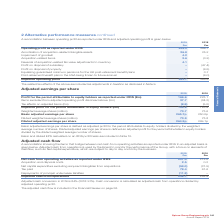According to Spirax Sarco Engineering Plc's financial document, What does the Board use Adjusted cash from operations for? to monitor the performance of the Group, with a focus on elements of cashflow, such as Net capital expenditure, which are subject to day to day control by the business. The document states: "djusted cash from operations is used by the Board to monitor the performance of the Group, with a focus on elements of cashflow, such as Net capital e..." Also, How is cash conversion calculated? as adjusted cash from operations divided by adjusted operating profit. The document states: "is 84% (2018: 91%). Cash conversion is calculated as adjusted cash from operations divided by adjusted operating profit...." Also, In which years was the adjusted cash conversion calculated in? The document shows two values: 2019 and 2018. From the document: "2019 2018 Profit for the period attributable to equity holders as reported under IFRS (£m) 166.6 223.1 I 2019 2018 Profit for the period attributable ..." Additionally, In which year was the adjusted cash from operations larger? According to the financial document, 2018. The relevant text states: "2019 2018 Profit for the period attributable to equity holders as reported under IFRS (£m) 166.6 223.1 Items..." Also, can you calculate: What was the percentage change in the adjusted cash conversion in 2019 from 2018? Based on the calculation: 91%-84%, the result is 7 (percentage). This is based on the information: "Adjusted cash conversion in 2019 is 84% (2018: 91%). Cash conversion is calculated as adjusted cash from operations divided by adjusted op Adjusted cash conversion in 2019 is 84% (2018: 91%). Cash con..." The key data points involved are: 84, 91. Also, can you calculate: What was the percentage change in the amount of tax paid in 2019 from 2018? To answer this question, I need to perform calculations using the financial data. The calculation is: (78.4-61.6)/61.6, which equals 27.27 (percentage). This is based on the information: "angibles from acquisitions (59.0) (31.5) Tax paid 78.4 61.6 Repayments of principal under lease liabilities (11.2) – Adjusted cash from operations 238.1 2 les from acquisitions (59.0) (31.5) Tax paid ..." The key data points involved are: 61.6, 78.4. 